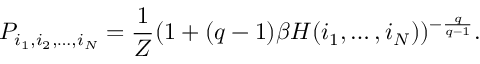<formula> <loc_0><loc_0><loc_500><loc_500>P _ { i _ { 1 } , i _ { 2 } , \dots , i _ { N } } = \frac { 1 } { Z } ( 1 + ( q - 1 ) \beta H ( i _ { 1 } , \dots , i _ { N } ) ) ^ { - \frac { q } { q - 1 } } .</formula> 